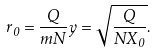Convert formula to latex. <formula><loc_0><loc_0><loc_500><loc_500>r _ { 0 } = \frac { Q } { m N } y = \sqrt { \frac { Q } { N X _ { 0 } } } .</formula> 